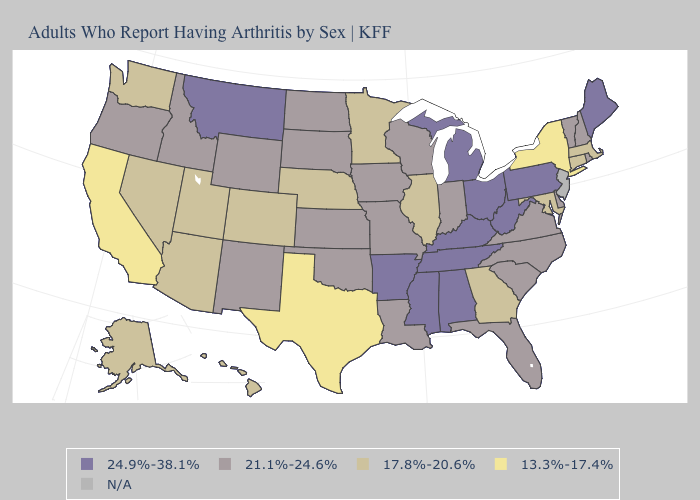Name the states that have a value in the range N/A?
Give a very brief answer. New Jersey. Name the states that have a value in the range 13.3%-17.4%?
Concise answer only. California, New York, Texas. Which states have the lowest value in the West?
Concise answer only. California. What is the lowest value in the USA?
Concise answer only. 13.3%-17.4%. Which states have the highest value in the USA?
Give a very brief answer. Alabama, Arkansas, Kentucky, Maine, Michigan, Mississippi, Montana, Ohio, Pennsylvania, Tennessee, West Virginia. What is the lowest value in the USA?
Give a very brief answer. 13.3%-17.4%. Name the states that have a value in the range 13.3%-17.4%?
Keep it brief. California, New York, Texas. What is the value of West Virginia?
Answer briefly. 24.9%-38.1%. Does Texas have the lowest value in the USA?
Keep it brief. Yes. Name the states that have a value in the range 21.1%-24.6%?
Quick response, please. Delaware, Florida, Idaho, Indiana, Iowa, Kansas, Louisiana, Missouri, New Hampshire, New Mexico, North Carolina, North Dakota, Oklahoma, Oregon, Rhode Island, South Carolina, South Dakota, Vermont, Virginia, Wisconsin, Wyoming. Among the states that border New Jersey , which have the lowest value?
Answer briefly. New York. 